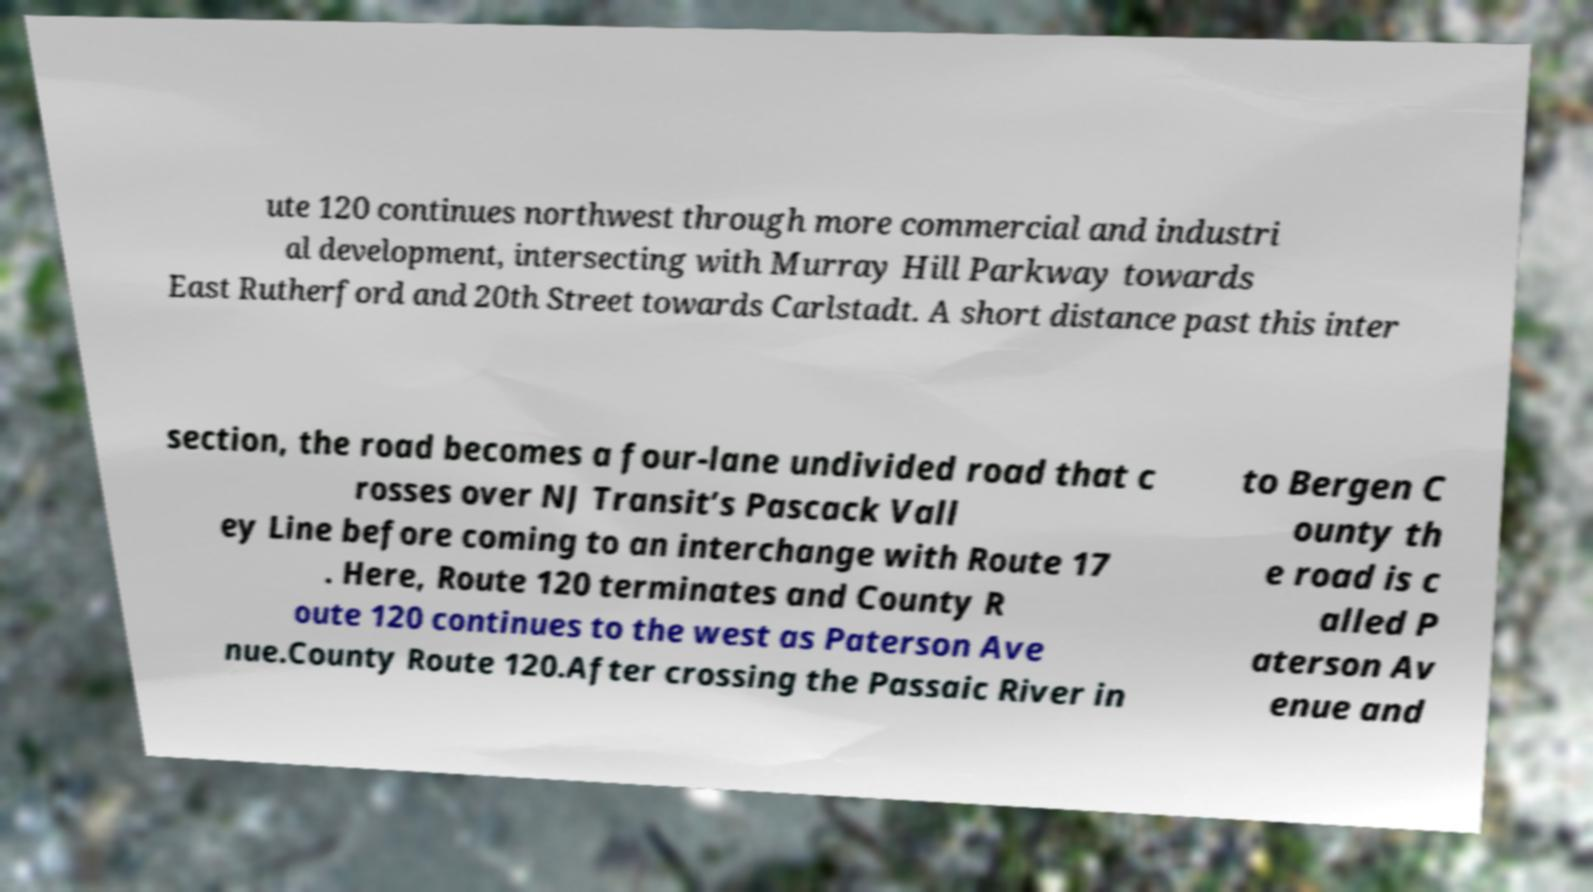There's text embedded in this image that I need extracted. Can you transcribe it verbatim? ute 120 continues northwest through more commercial and industri al development, intersecting with Murray Hill Parkway towards East Rutherford and 20th Street towards Carlstadt. A short distance past this inter section, the road becomes a four-lane undivided road that c rosses over NJ Transit’s Pascack Vall ey Line before coming to an interchange with Route 17 . Here, Route 120 terminates and County R oute 120 continues to the west as Paterson Ave nue.County Route 120.After crossing the Passaic River in to Bergen C ounty th e road is c alled P aterson Av enue and 